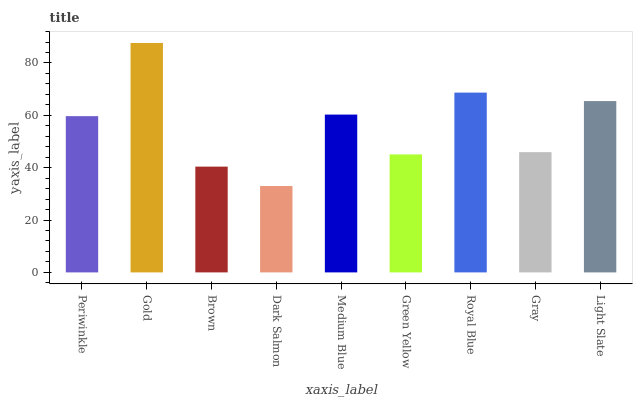Is Dark Salmon the minimum?
Answer yes or no. Yes. Is Gold the maximum?
Answer yes or no. Yes. Is Brown the minimum?
Answer yes or no. No. Is Brown the maximum?
Answer yes or no. No. Is Gold greater than Brown?
Answer yes or no. Yes. Is Brown less than Gold?
Answer yes or no. Yes. Is Brown greater than Gold?
Answer yes or no. No. Is Gold less than Brown?
Answer yes or no. No. Is Periwinkle the high median?
Answer yes or no. Yes. Is Periwinkle the low median?
Answer yes or no. Yes. Is Medium Blue the high median?
Answer yes or no. No. Is Light Slate the low median?
Answer yes or no. No. 